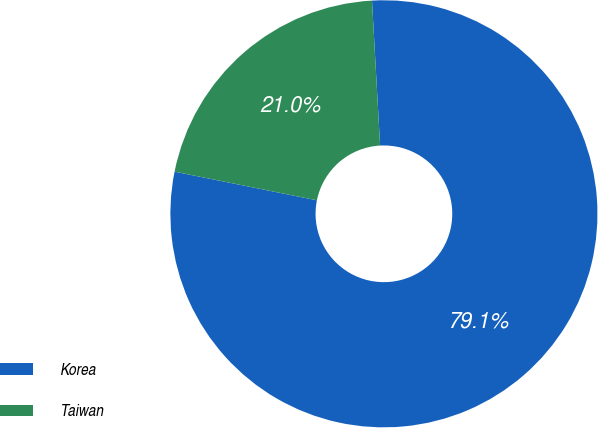Convert chart. <chart><loc_0><loc_0><loc_500><loc_500><pie_chart><fcel>Korea<fcel>Taiwan<nl><fcel>79.05%<fcel>20.95%<nl></chart> 